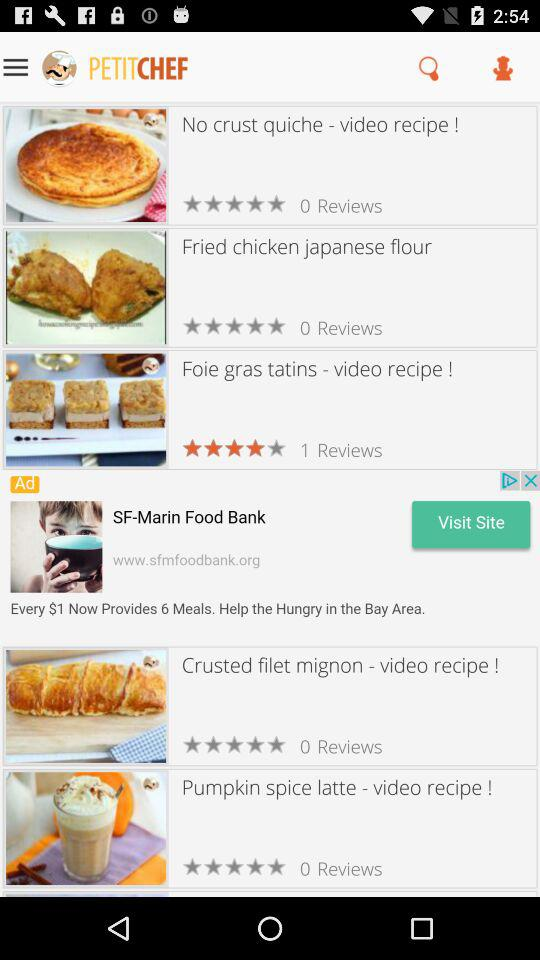What is the name of the application? The name of the application is "PETITCHEF". 